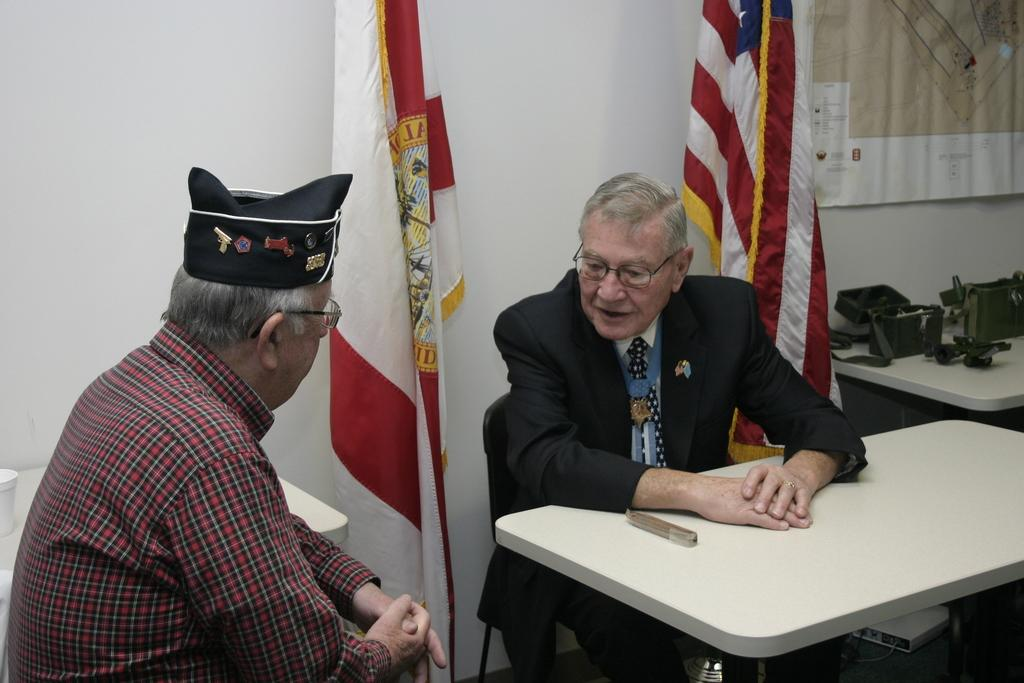How many people are in the image? There are two men in the image. What are the men doing in the image? The men are sitting on chairs. What can be seen on the faces of the men? Both men are wearing glasses. What can be seen in the background of the image? There are two flags and additional items on the table in the background. What type of plants can be seen growing in the image? There are no plants visible in the image. What season is depicted in the image? The image does not show any specific season, so it cannot be determined if it is winter or any other season. 